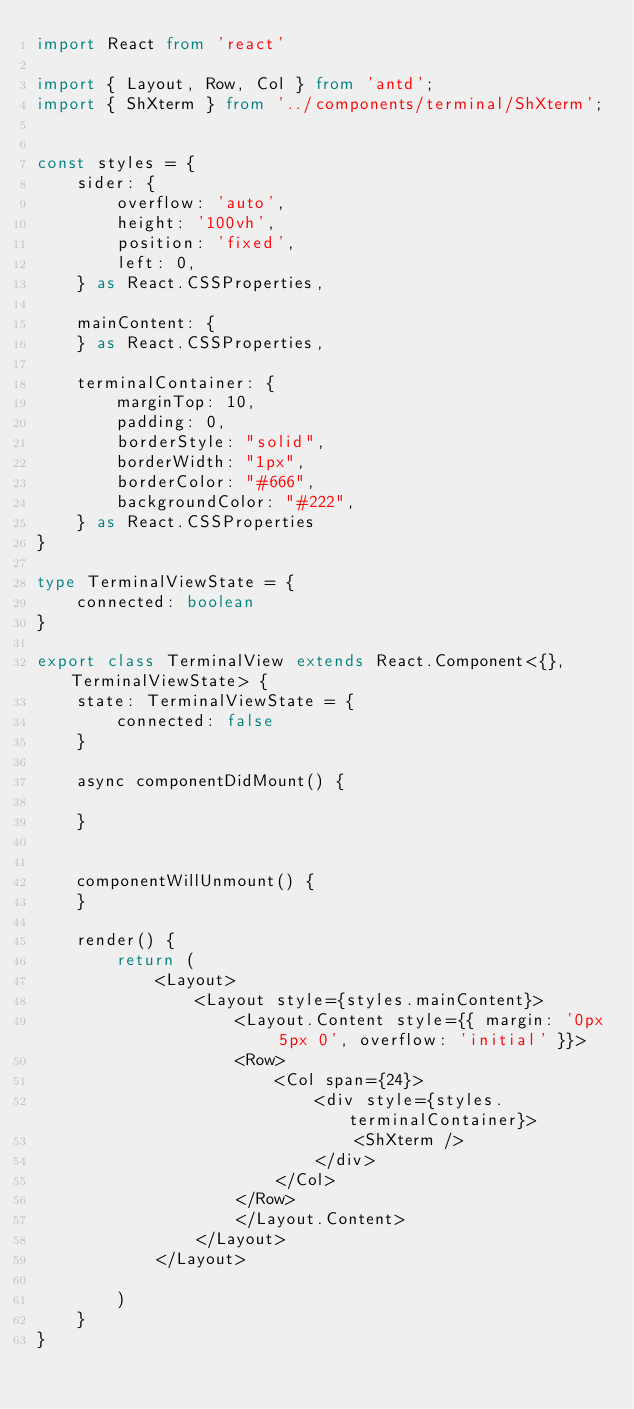Convert code to text. <code><loc_0><loc_0><loc_500><loc_500><_TypeScript_>import React from 'react'

import { Layout, Row, Col } from 'antd';
import { ShXterm } from '../components/terminal/ShXterm';


const styles = {
    sider: {
        overflow: 'auto',
        height: '100vh',
        position: 'fixed',
        left: 0,
    } as React.CSSProperties,

    mainContent: {
    } as React.CSSProperties,
    
    terminalContainer: {
        marginTop: 10, 
        padding: 0,
        borderStyle: "solid",
        borderWidth: "1px",
        borderColor: "#666",
        backgroundColor: "#222",
    } as React.CSSProperties
}

type TerminalViewState = {
    connected: boolean
}

export class TerminalView extends React.Component<{}, TerminalViewState> {
    state: TerminalViewState = {
        connected: false
    }

    async componentDidMount() {
        
    }


    componentWillUnmount() {
    }

    render() {
        return (
            <Layout>
                <Layout style={styles.mainContent}>
                    <Layout.Content style={{ margin: '0px 5px 0', overflow: 'initial' }}>
                    <Row>
                        <Col span={24}>
                            <div style={styles.terminalContainer}>
                                <ShXterm />
                            </div>
                        </Col>
                    </Row>
                    </Layout.Content>
                </Layout>
            </Layout>
            
        )
    }
}</code> 